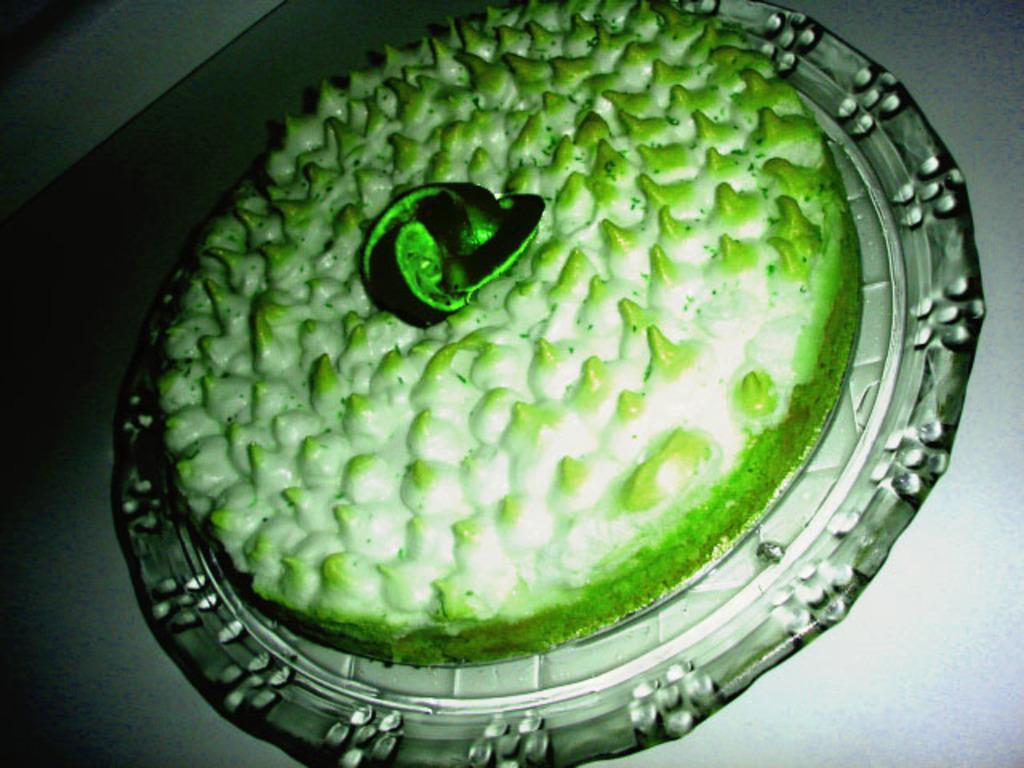Please provide a concise description of this image. In this image there is a cake on a plate. The plate is on a surface. 